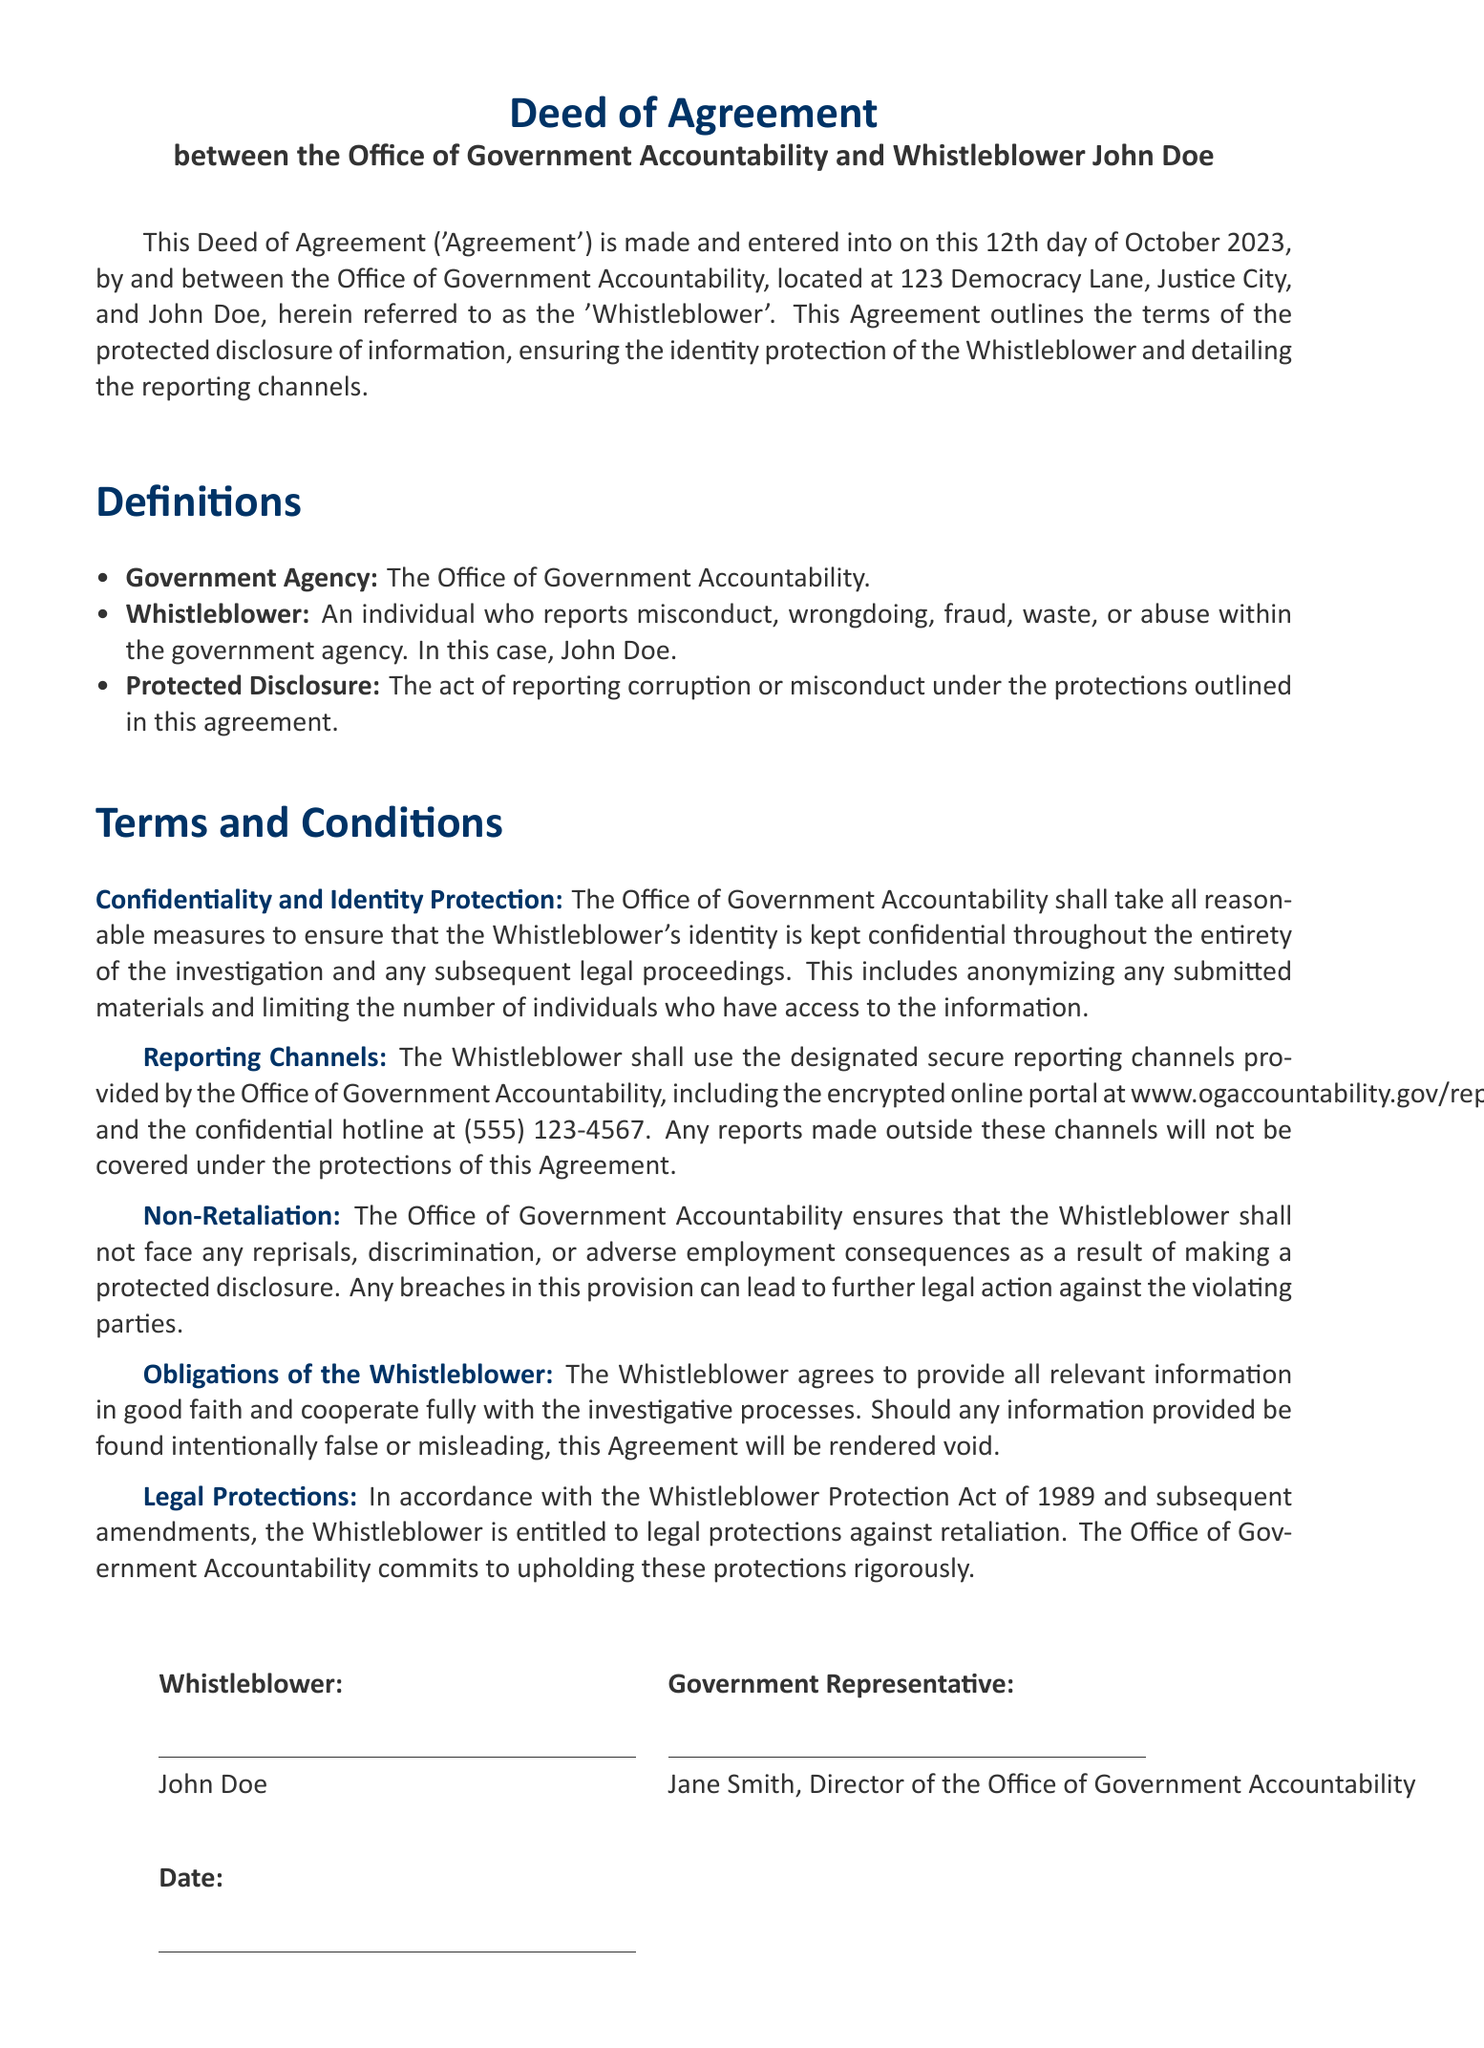What is the date of the agreement? The date when the agreement was made is stated in the document.
Answer: October 12, 2023 Who is the whistleblower named in the document? The name of the whistleblower is explicitly mentioned in the document.
Answer: John Doe What is the name of the government agency involved in the agreement? The document specifies the title of the agency.
Answer: Office of Government Accountability What is the hotline number provided for reporting? The document includes a specific hotline number for reports.
Answer: (555) 123-4567 What does the term "Protected Disclosure" refer to in this agreement? The document provides a definition of this term.
Answer: The act of reporting corruption or misconduct Which act protects the whistleblower from retaliation? The document cites a specific act related to whistleblower protections.
Answer: Whistleblower Protection Act of 1989 What should the whistleblower do if they provide false information? The document outlines the consequences of providing false information.
Answer: This Agreement will be rendered void What is the color of the header in the document? The document uses a specific color for the header.
Answer: RGB(0,51,102) 